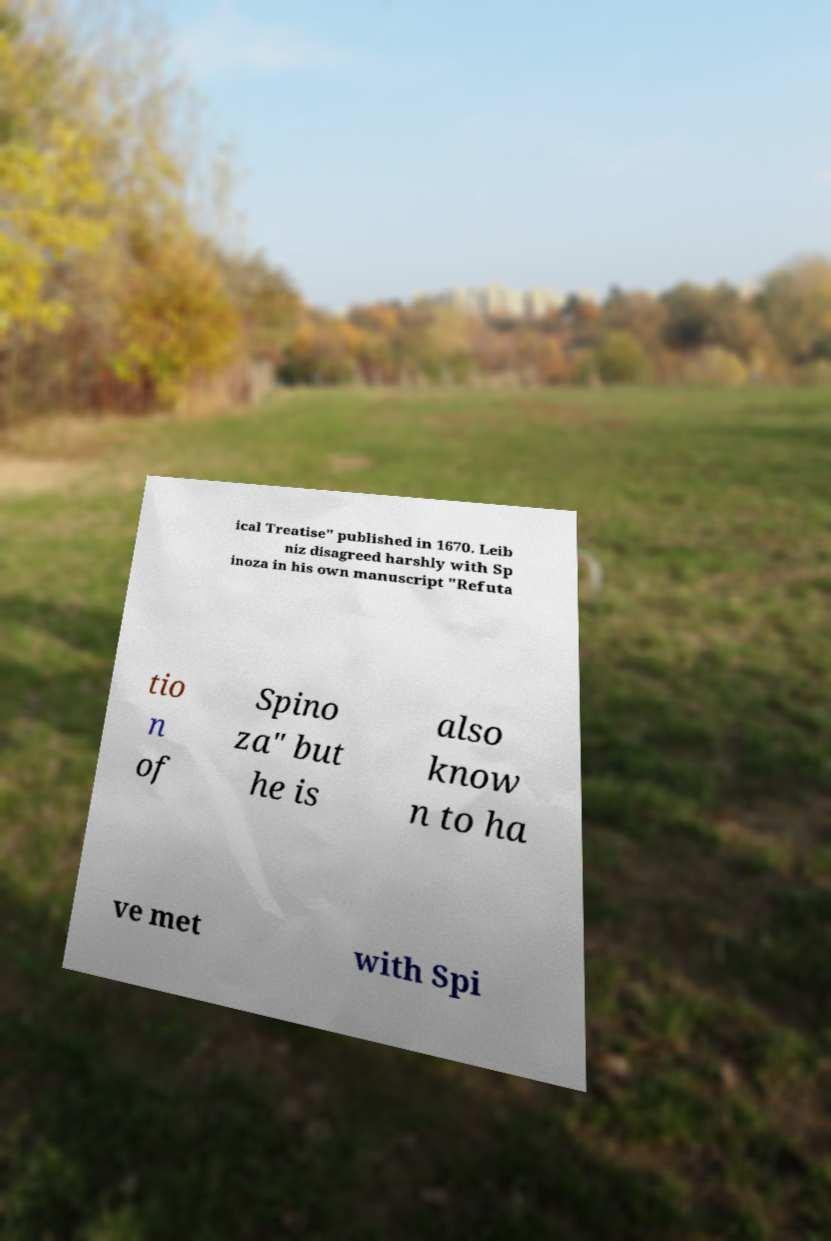I need the written content from this picture converted into text. Can you do that? ical Treatise" published in 1670. Leib niz disagreed harshly with Sp inoza in his own manuscript "Refuta tio n of Spino za" but he is also know n to ha ve met with Spi 